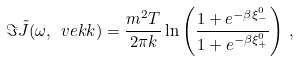Convert formula to latex. <formula><loc_0><loc_0><loc_500><loc_500>\Im \tilde { J } ( \omega , \ v e k { k } ) = \frac { m ^ { 2 } T } { 2 \pi k } \ln \left ( \frac { 1 + e ^ { - \beta \xi ^ { 0 } _ { - } } } { 1 + e ^ { - \beta \xi ^ { 0 } _ { + } } } \right ) \, ,</formula> 